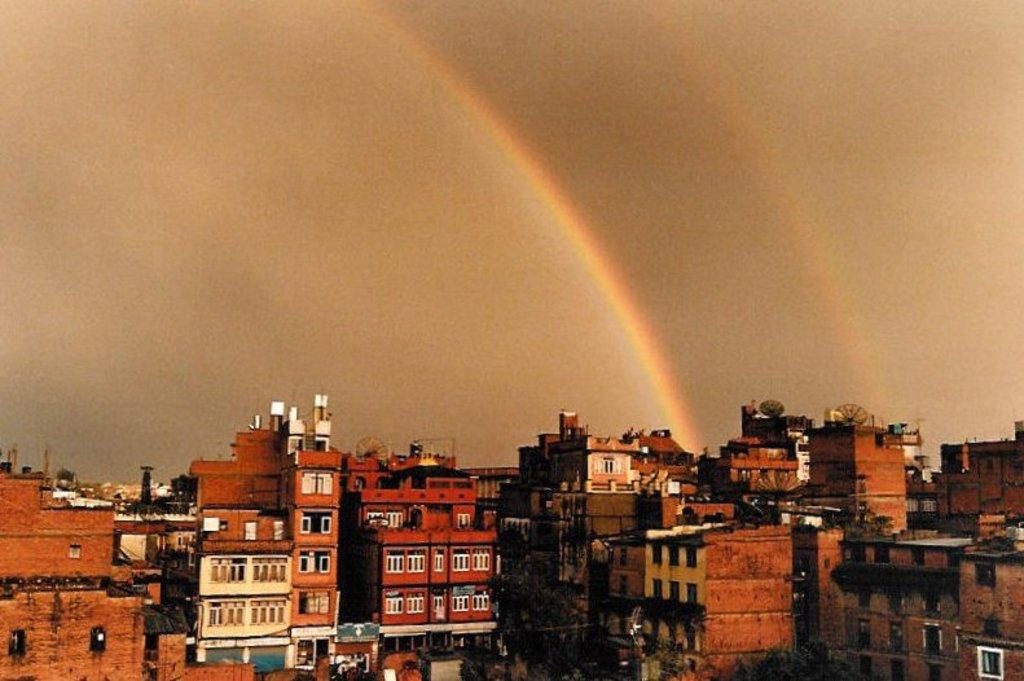What type of structures can be seen in the image? There are buildings in the image. What else is present in the image besides the buildings? There are trees in the image. What feature do the buildings have? The buildings have glass windows. What natural phenomenon can be seen in the sky in the background of the image? There is a rainbow visible in the sky in the background of the image. Where is the pig located in the image? There is no pig present in the image. What type of stem can be seen growing from the trees in the image? There is no specific stem mentioned or visible in the image; it simply shows trees. 